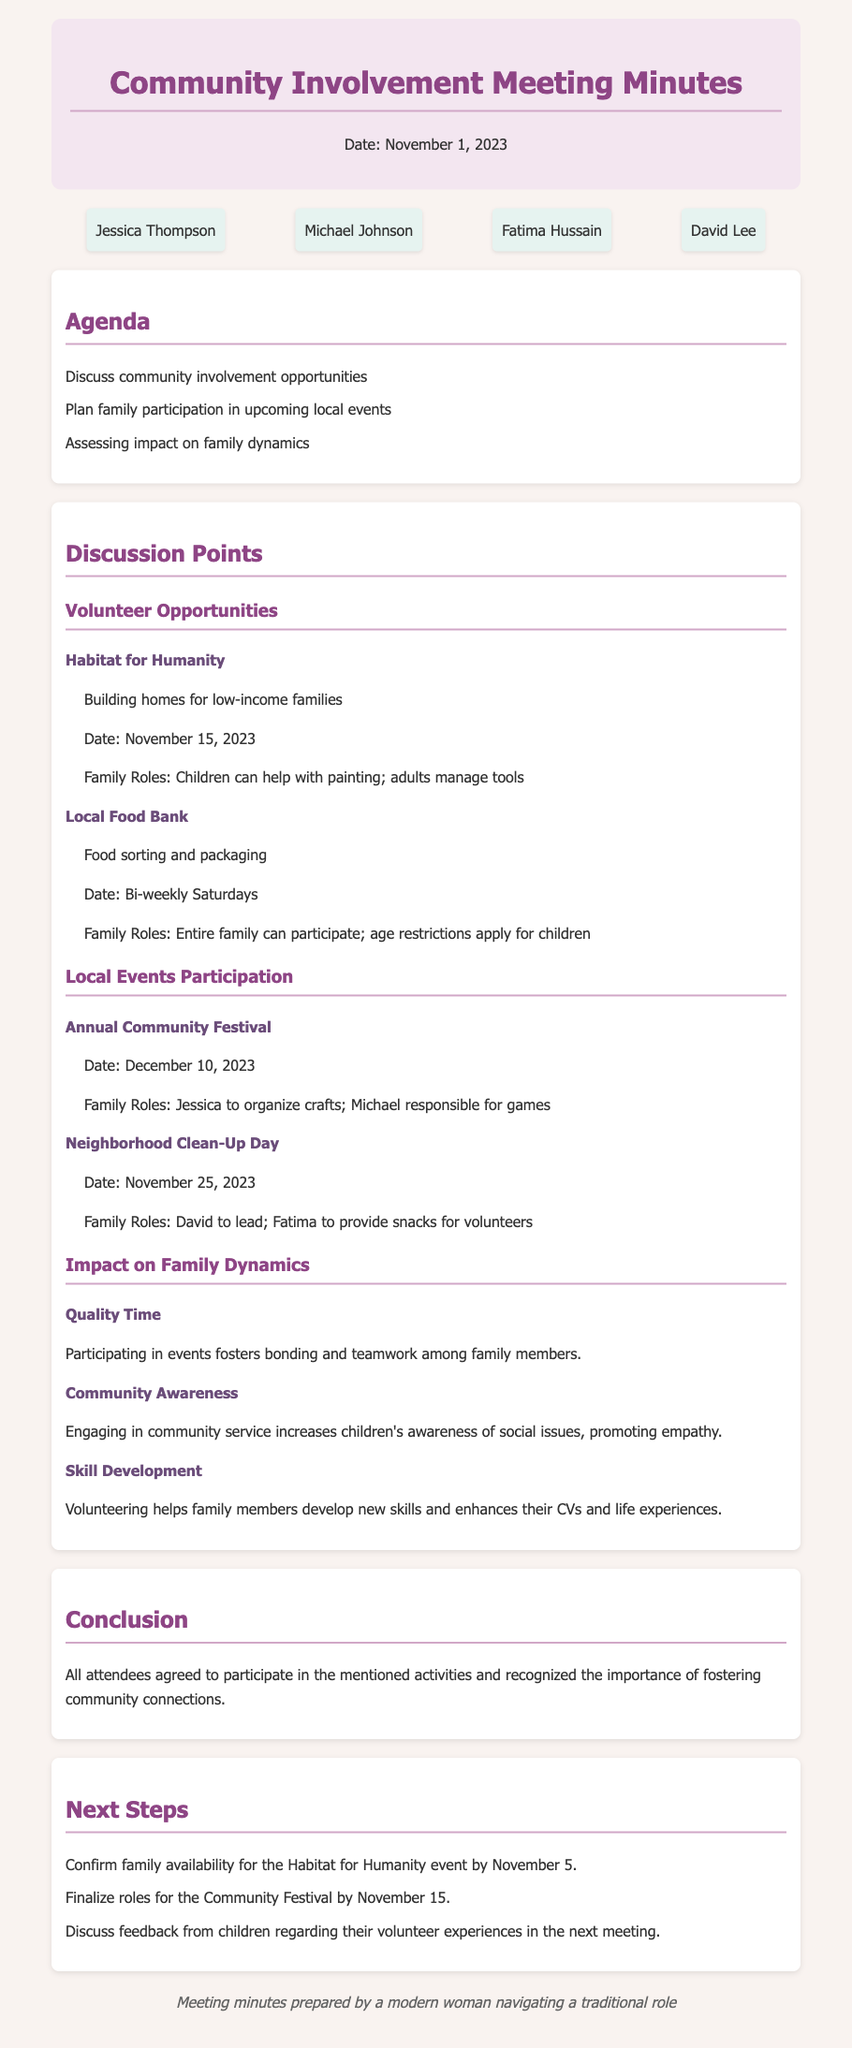What is the date of the Community Involvement Meeting? The date is specified at the top of the document.
Answer: November 1, 2023 Who is responsible for organizing crafts at the Annual Community Festival? The document identifies roles for the festival under local events participation.
Answer: Jessica What type of volunteer work is associated with Habitat for Humanity? The specific task is described under volunteer opportunities in the discussion section.
Answer: Building homes When is the Neighborhood Clean-Up Day scheduled? The date is listed under local events participation.
Answer: November 25, 2023 What is one benefit of participating in community events mentioned in the discussion? The impact on family dynamics discussed highlights the benefits of involvement.
Answer: Quality Time How many volunteer opportunities were discussed in the meeting? The sections under volunteer opportunities detail the discussed opportunities.
Answer: Two What is the role of Fatima in the Neighborhood Clean-Up Day? Her specific contribution is mentioned in the local events participation section.
Answer: Provide snacks When is the feedback from children regarding their volunteer experiences to be discussed? This is noted in the next steps section towards the end of the document.
Answer: Next meeting 